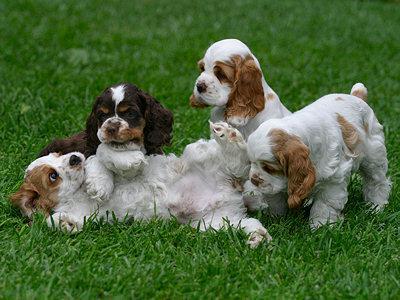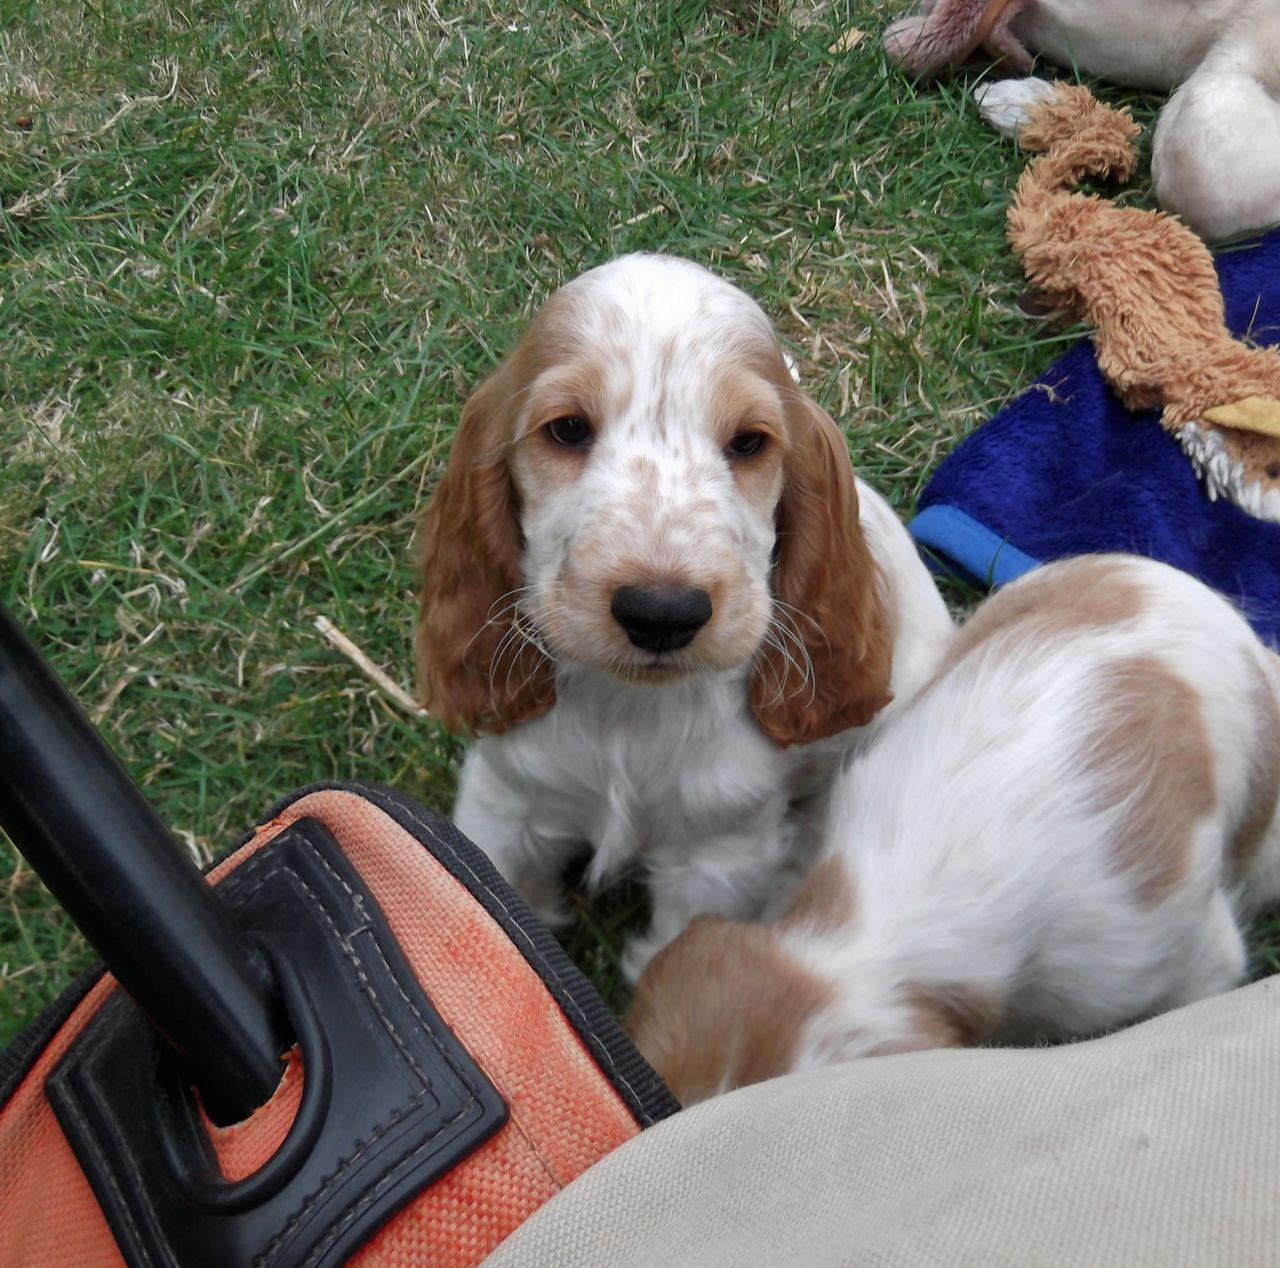The first image is the image on the left, the second image is the image on the right. Considering the images on both sides, is "Two dogs are playing in the grass in the left image, and the right image includes an orange spaniel with an open mouth." valid? Answer yes or no. No. The first image is the image on the left, the second image is the image on the right. Considering the images on both sides, is "The right image contains no more than one dog." valid? Answer yes or no. No. 